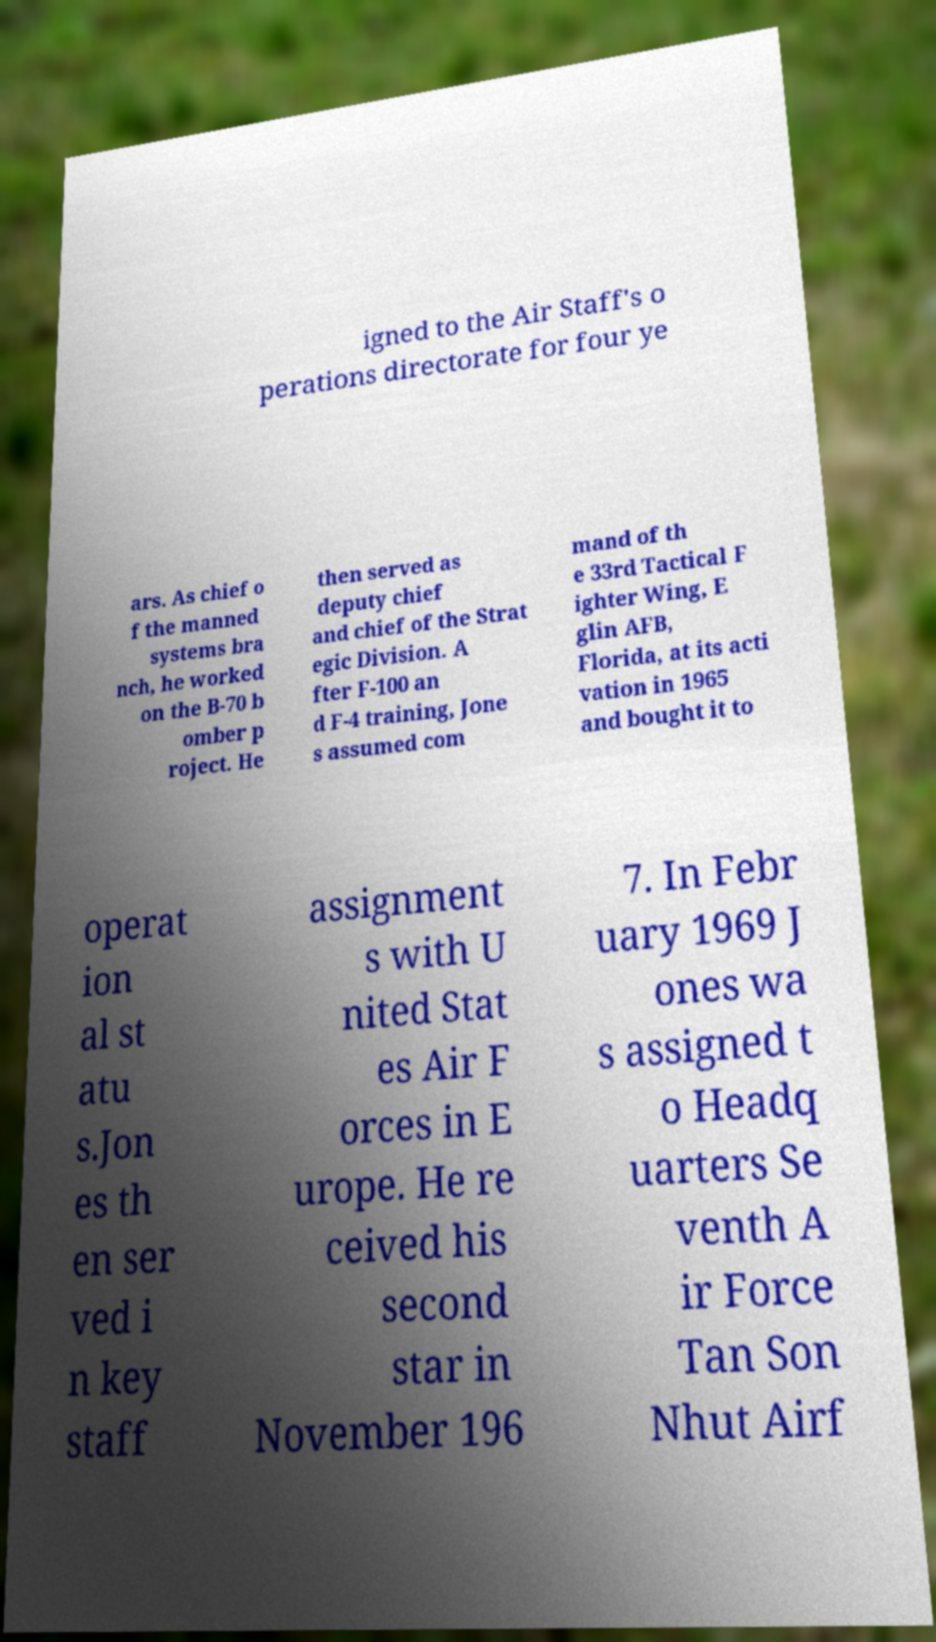For documentation purposes, I need the text within this image transcribed. Could you provide that? igned to the Air Staff's o perations directorate for four ye ars. As chief o f the manned systems bra nch, he worked on the B-70 b omber p roject. He then served as deputy chief and chief of the Strat egic Division. A fter F-100 an d F-4 training, Jone s assumed com mand of th e 33rd Tactical F ighter Wing, E glin AFB, Florida, at its acti vation in 1965 and bought it to operat ion al st atu s.Jon es th en ser ved i n key staff assignment s with U nited Stat es Air F orces in E urope. He re ceived his second star in November 196 7. In Febr uary 1969 J ones wa s assigned t o Headq uarters Se venth A ir Force Tan Son Nhut Airf 